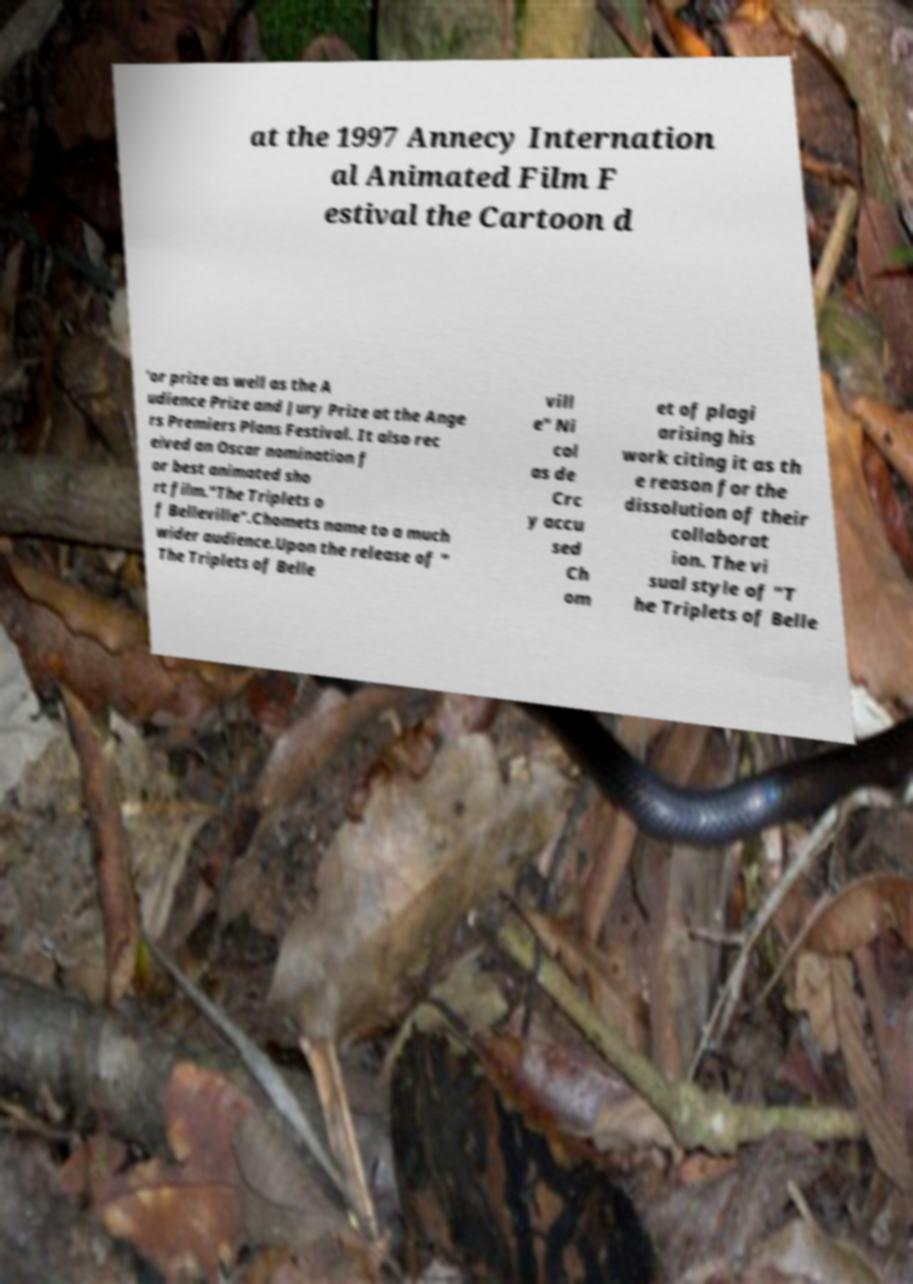Can you read and provide the text displayed in the image?This photo seems to have some interesting text. Can you extract and type it out for me? at the 1997 Annecy Internation al Animated Film F estival the Cartoon d 'or prize as well as the A udience Prize and Jury Prize at the Ange rs Premiers Plans Festival. It also rec eived an Oscar nomination f or best animated sho rt film."The Triplets o f Belleville".Chomets name to a much wider audience.Upon the release of " The Triplets of Belle vill e" Ni col as de Crc y accu sed Ch om et of plagi arising his work citing it as th e reason for the dissolution of their collaborat ion. The vi sual style of "T he Triplets of Belle 